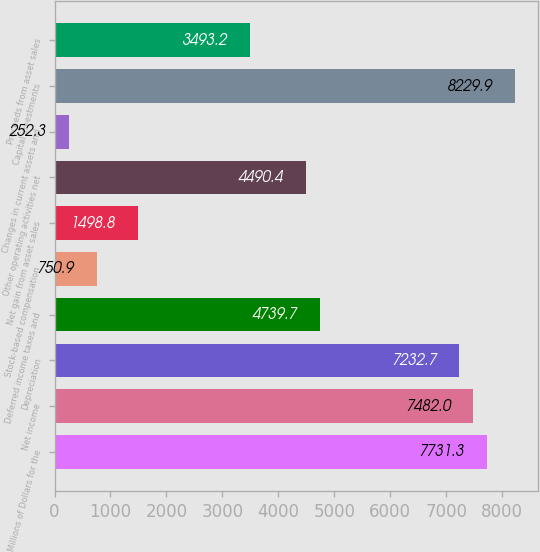Convert chart to OTSL. <chart><loc_0><loc_0><loc_500><loc_500><bar_chart><fcel>Millions of Dollars for the<fcel>Net income<fcel>Depreciation<fcel>Deferred income taxes and<fcel>Stock-based compensation<fcel>Net gain from asset sales<fcel>Other operating activities net<fcel>Changes in current assets and<fcel>Capital investments<fcel>Proceeds from asset sales<nl><fcel>7731.3<fcel>7482<fcel>7232.7<fcel>4739.7<fcel>750.9<fcel>1498.8<fcel>4490.4<fcel>252.3<fcel>8229.9<fcel>3493.2<nl></chart> 